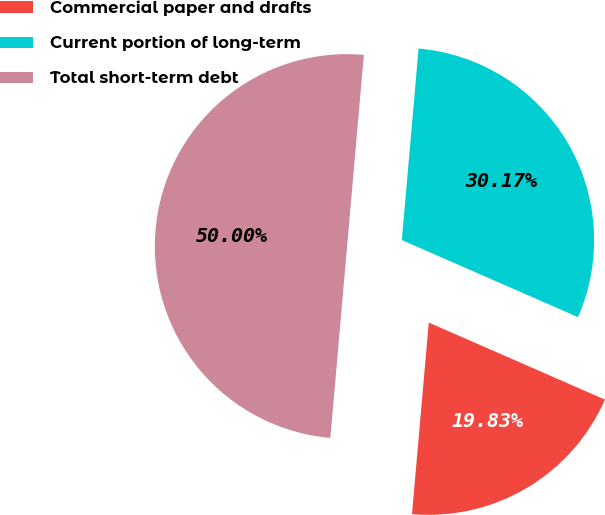Convert chart. <chart><loc_0><loc_0><loc_500><loc_500><pie_chart><fcel>Commercial paper and drafts<fcel>Current portion of long-term<fcel>Total short-term debt<nl><fcel>19.83%<fcel>30.17%<fcel>50.0%<nl></chart> 